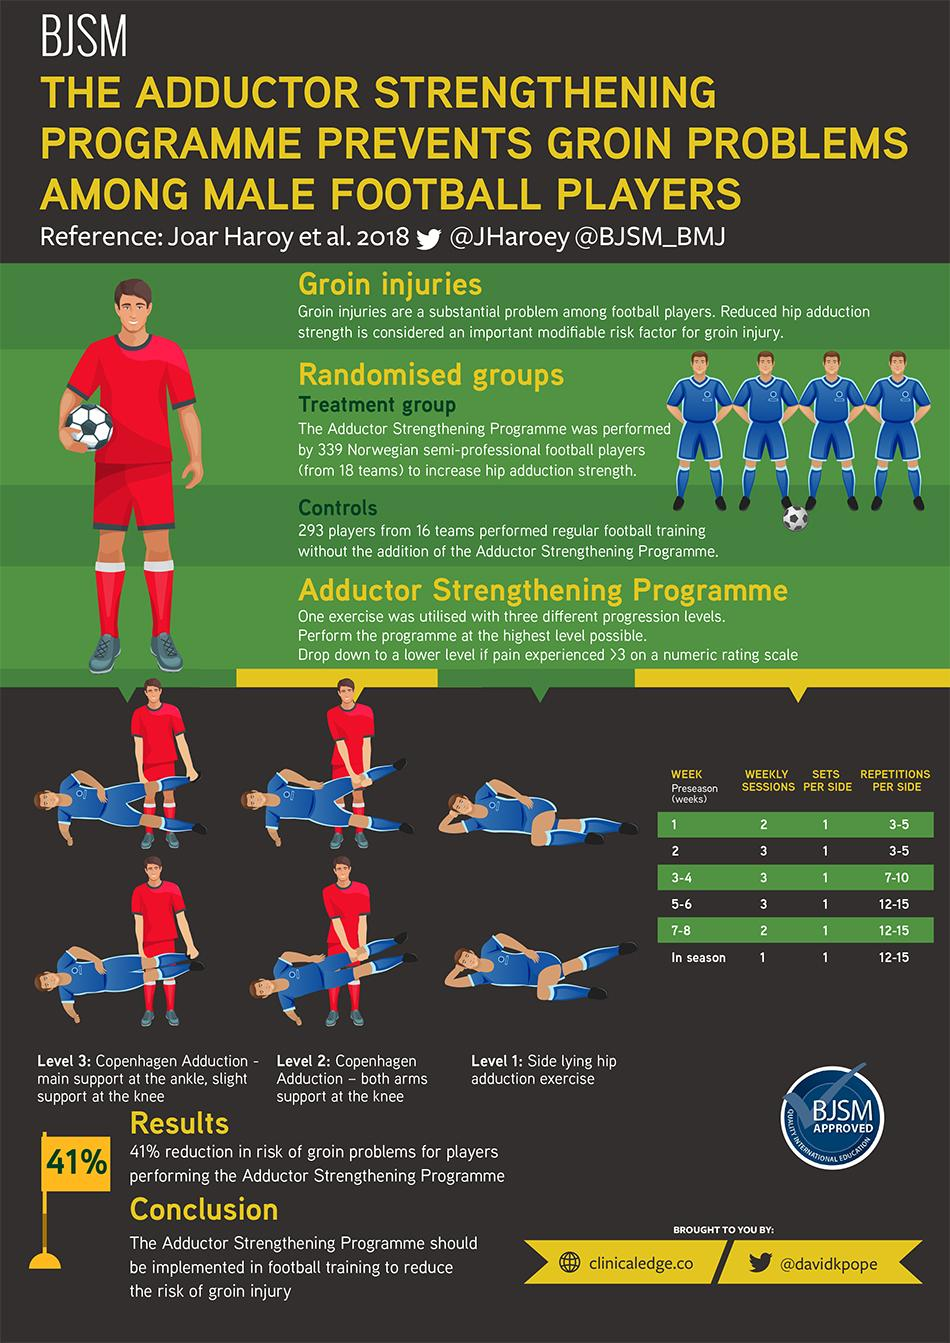Highlight a few significant elements in this photo. During the 5-6 week phase, 12-15 repetitions per side should be performed. During the 7-8 week phase, 12-15 repetitions per side should be performed. And during the in-season phase, 12-15 repetitions per side should be performed What sets per side must be completed every single week of the preseason? A count of 1.. During weeks 1, 5, and 6 of the Adductor Strengthening Programme, a total of two weekly sessions must be conducted. The Adductor Strengthening Programme includes weeks with repetitions per side ranging from 3 to 5, specifically weeks 1 and 2. During which weeks of the Adductor Strengthening Programme did the participant complete three weekly sessions? 